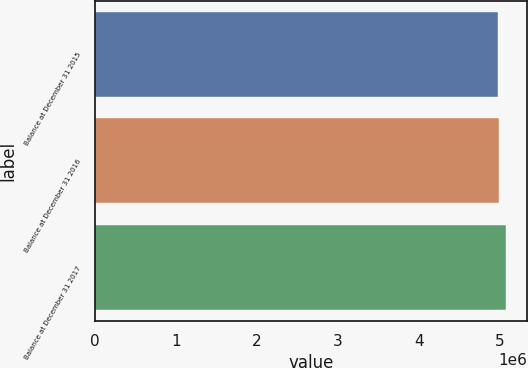<chart> <loc_0><loc_0><loc_500><loc_500><bar_chart><fcel>Balance at December 31 2015<fcel>Balance at December 31 2016<fcel>Balance at December 31 2017<nl><fcel>4.97202e+06<fcel>4.98252e+06<fcel>5.07704e+06<nl></chart> 